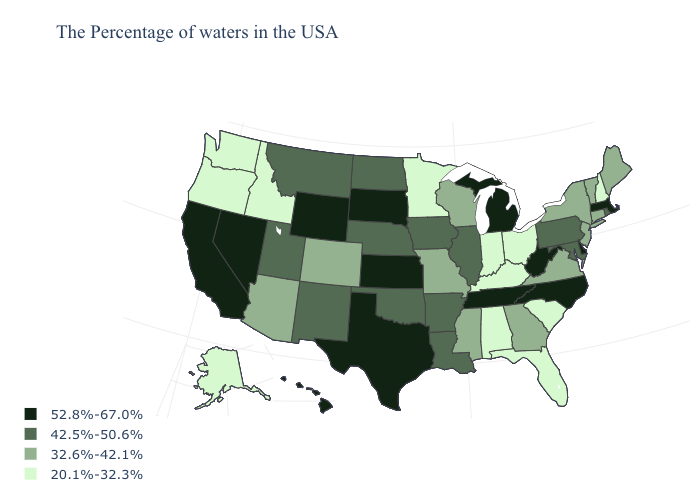Among the states that border Florida , which have the lowest value?
Quick response, please. Alabama. Is the legend a continuous bar?
Concise answer only. No. Does Massachusetts have the lowest value in the Northeast?
Answer briefly. No. Name the states that have a value in the range 42.5%-50.6%?
Be succinct. Rhode Island, Maryland, Pennsylvania, Illinois, Louisiana, Arkansas, Iowa, Nebraska, Oklahoma, North Dakota, New Mexico, Utah, Montana. Which states have the highest value in the USA?
Quick response, please. Massachusetts, Delaware, North Carolina, West Virginia, Michigan, Tennessee, Kansas, Texas, South Dakota, Wyoming, Nevada, California, Hawaii. Does Arkansas have a lower value than Texas?
Be succinct. Yes. What is the value of New Hampshire?
Answer briefly. 20.1%-32.3%. Among the states that border Oregon , which have the highest value?
Keep it brief. Nevada, California. Does Connecticut have the lowest value in the USA?
Give a very brief answer. No. Name the states that have a value in the range 52.8%-67.0%?
Answer briefly. Massachusetts, Delaware, North Carolina, West Virginia, Michigan, Tennessee, Kansas, Texas, South Dakota, Wyoming, Nevada, California, Hawaii. Does Mississippi have a higher value than North Carolina?
Concise answer only. No. Among the states that border South Dakota , which have the lowest value?
Quick response, please. Minnesota. Which states have the lowest value in the West?
Keep it brief. Idaho, Washington, Oregon, Alaska. Which states have the lowest value in the MidWest?
Give a very brief answer. Ohio, Indiana, Minnesota. 